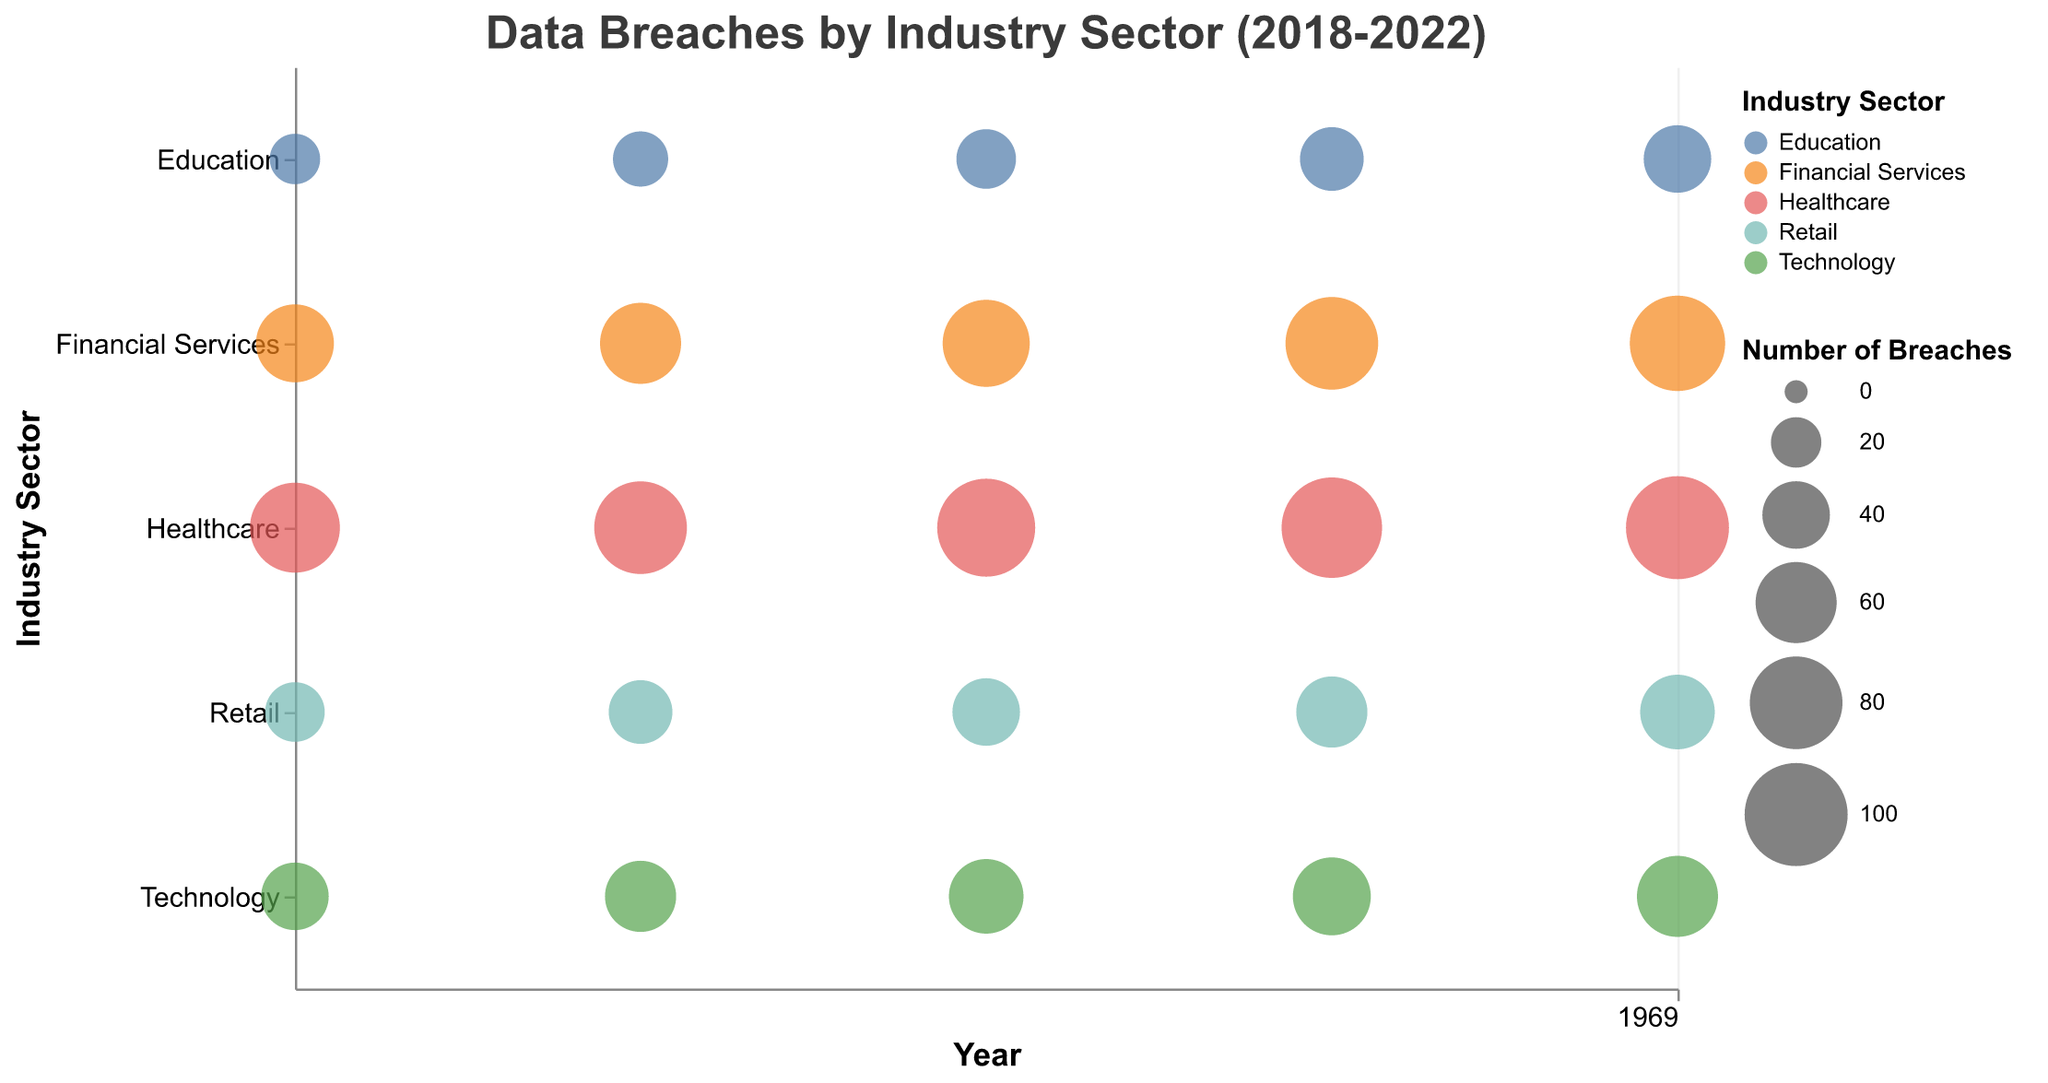How many industry sectors are shown in the figure? The figure shows distinct color-coded industry sectors on the y-axis, which are Healthcare, Financial Services, Technology, Retail, and Education. We can count these colors or read the axis labels.
Answer: 5 Which year had the highest number of breaches in the Healthcare sector? By examining the size of the bubbles for Healthcare across the years, 2022 has the largest bubble, indicating it had the highest number of breaches.
Answer: 2022 What is the range of data sensitivity scores across all sectors in 2020? We need to examine the tooltip information for all sectors in 2020. The lowest sensitivity score is from Retail (0.65), and the highest is from Healthcare (0.95). The range is 0.95 - 0.65.
Answer: 0.30 Which industry sector had the highest sensitivity score in 2018? By examining the tooltip information for all bubbles in 2018, the Financial Services sector has the highest sensitivity score of 0.90.
Answer: Financial Services How did the number of breaches in the Technology sector change from 2018 to 2022? Analyzing the bubble sizes in the Technology sector from 2018 to 2022, we see an increase in the number of breaches from 40 in 2018 to 60 in 2022.
Answer: Increased Which industry has shown the most significant increase in the number of breaches from 2018 to 2022? Calculating the difference in the number of breaches from 2018 to 2022 for each industry, Healthcare has the highest increase: 100 (2022) - 75 (2018) = 25 breaches.
Answer: Healthcare Compare the sensitivity scores between Financial Services and Retail sectors in 2022. Checking the sensitivity scores for both sectors in 2022, Financial Services has a sensitivity score of 0.88, while Retail has a score of 0.67.
Answer: Financial Services has higher sensitivity Which sector experienced a declining trend in the number of breaches from 2018 to 2022? All sectors show an increasing or stable number of breaches over the years; none show a declining trend.
Answer: None What is the average number of breaches in the Education sector from 2018 to 2022? Adding the number of breaches in the Education sector (20 + 25 + 30 + 35 + 40) and dividing by 5, we get an average of 30.
Answer: 30 